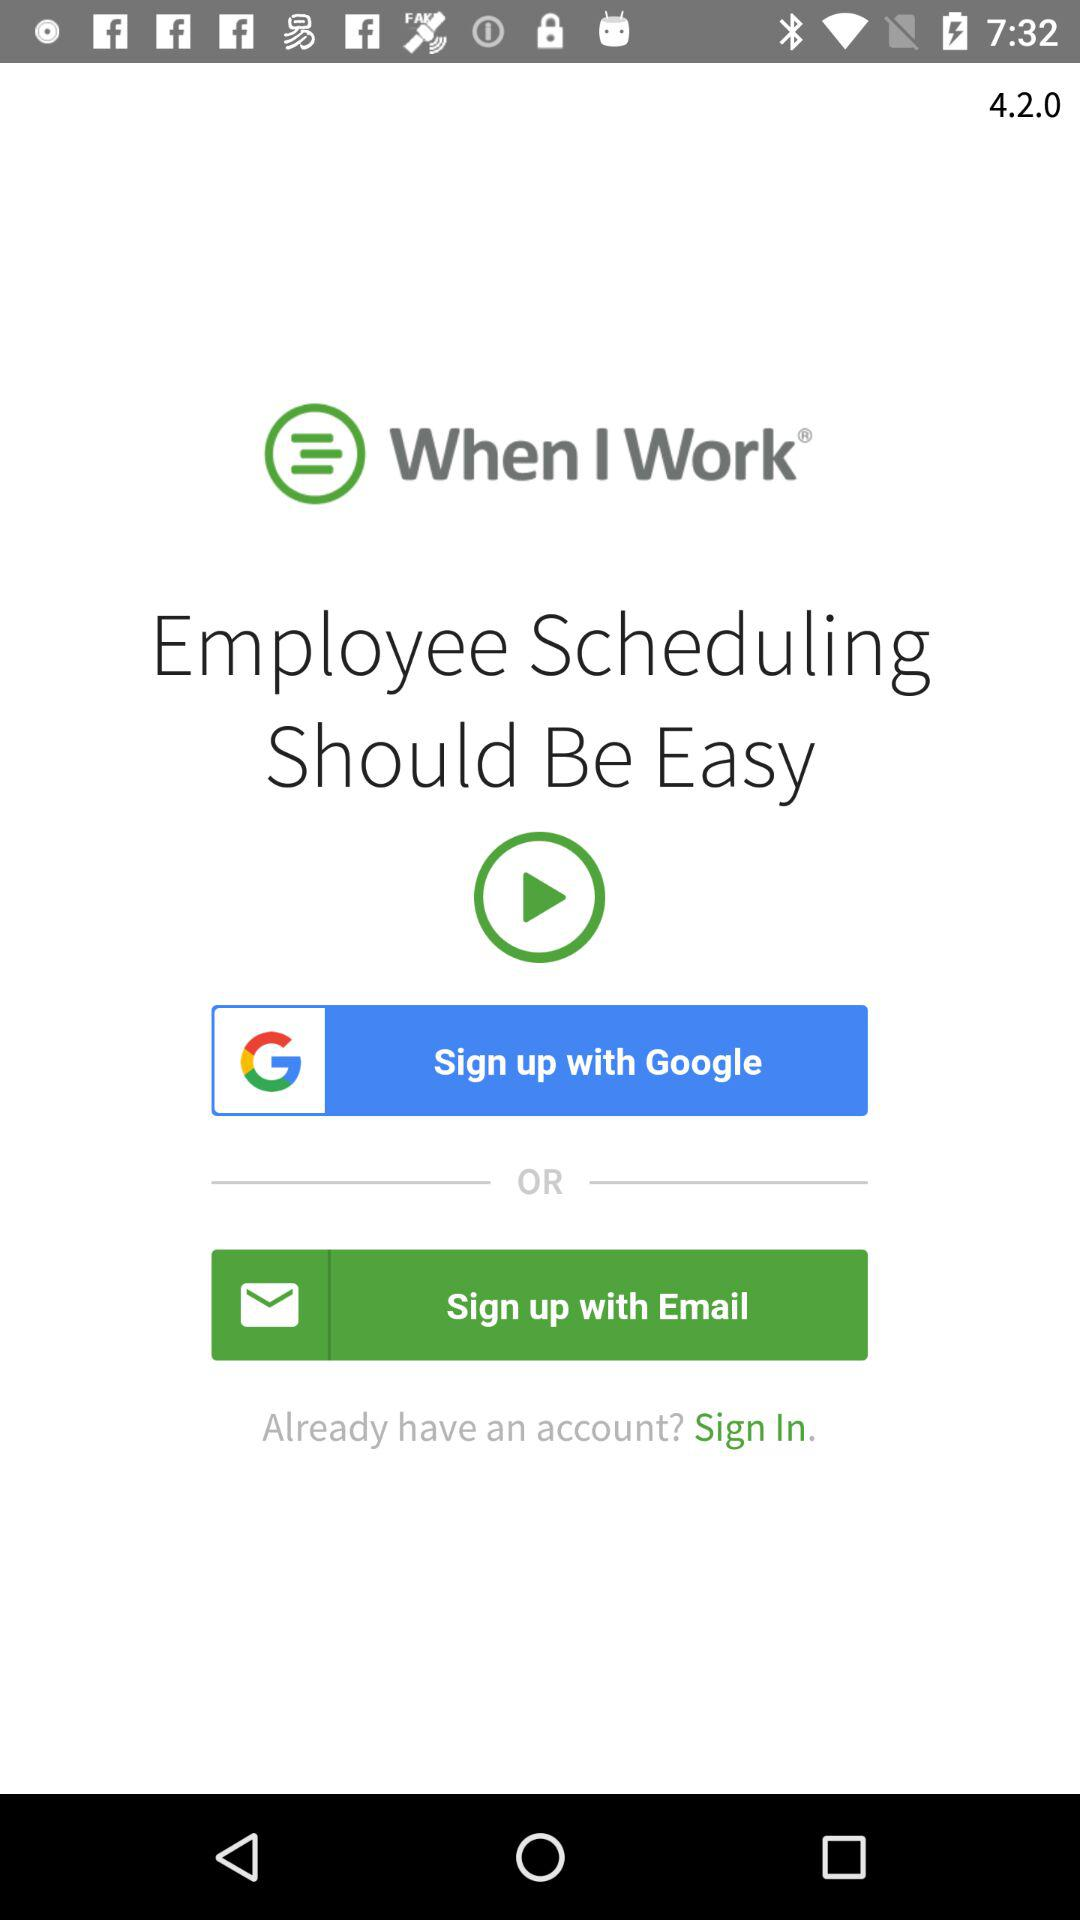How many sign up options are there?
Answer the question using a single word or phrase. 2 